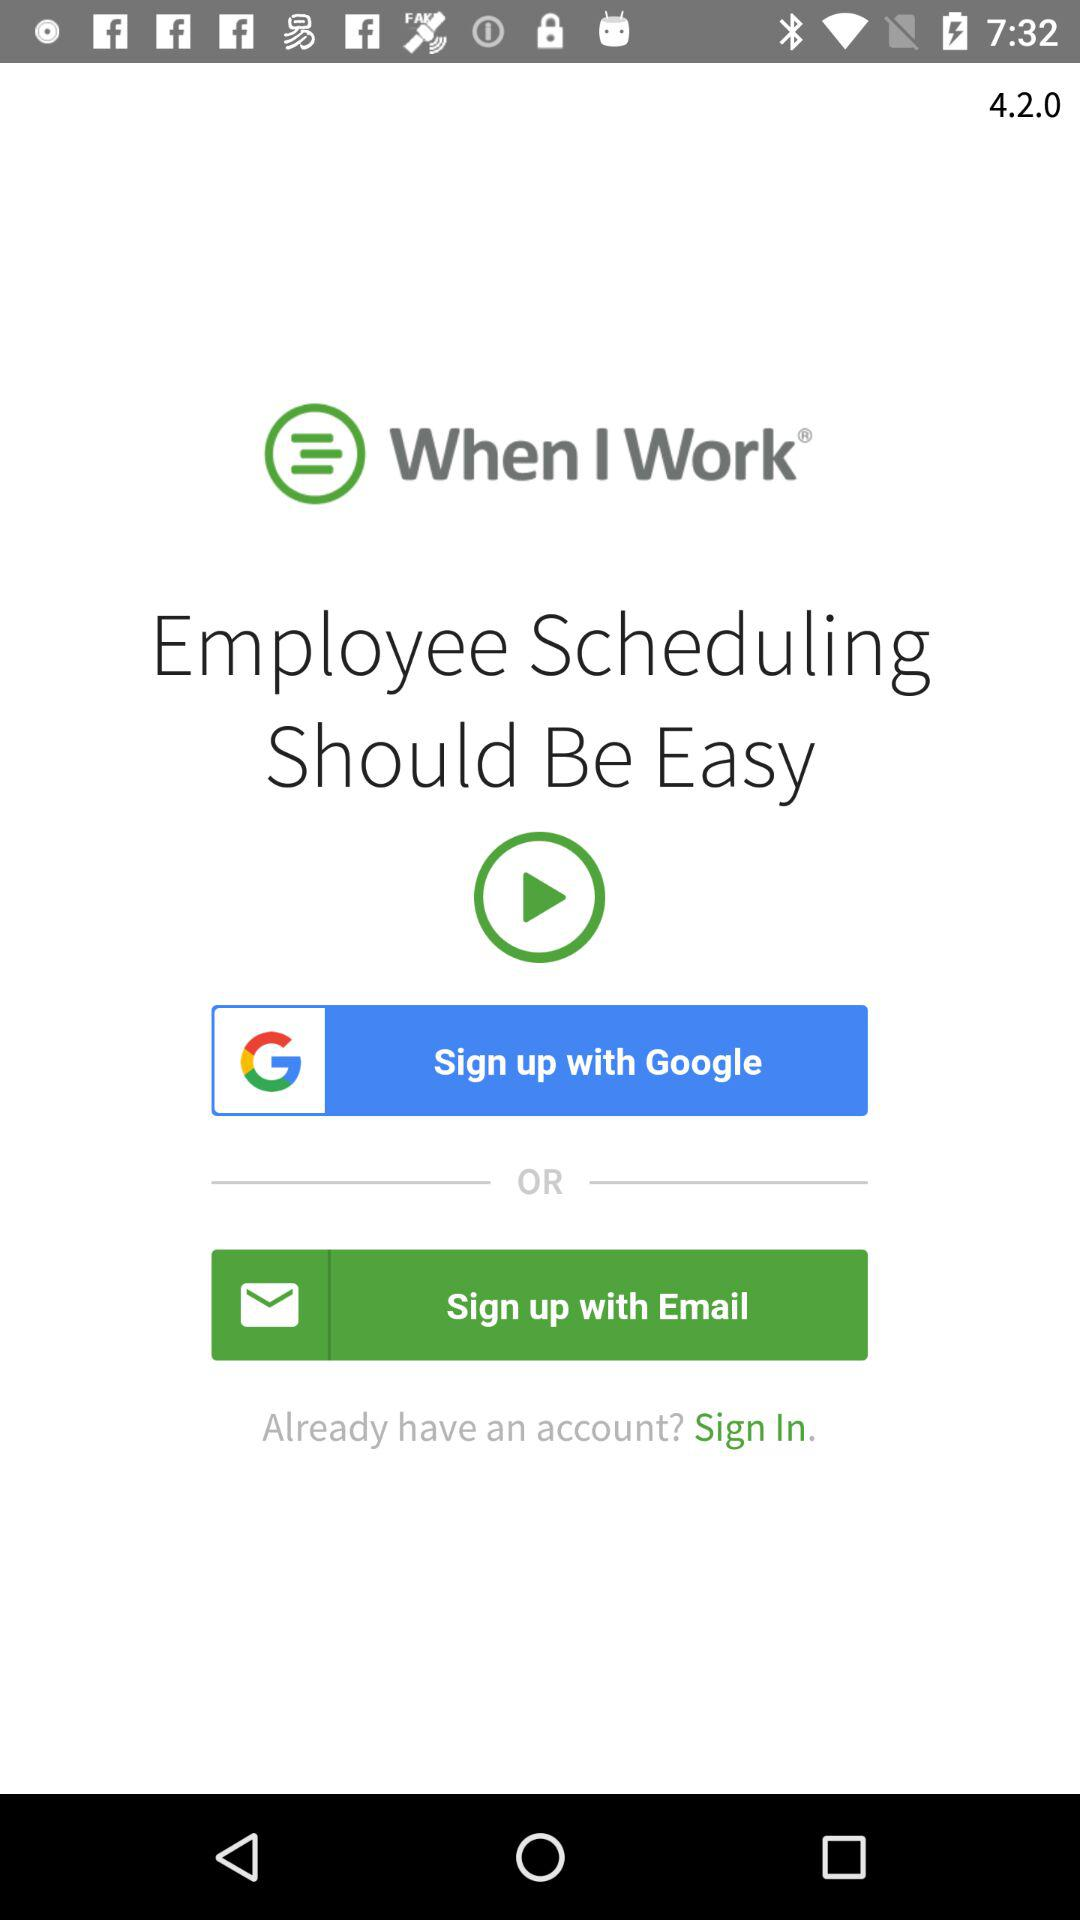How many sign up options are there?
Answer the question using a single word or phrase. 2 